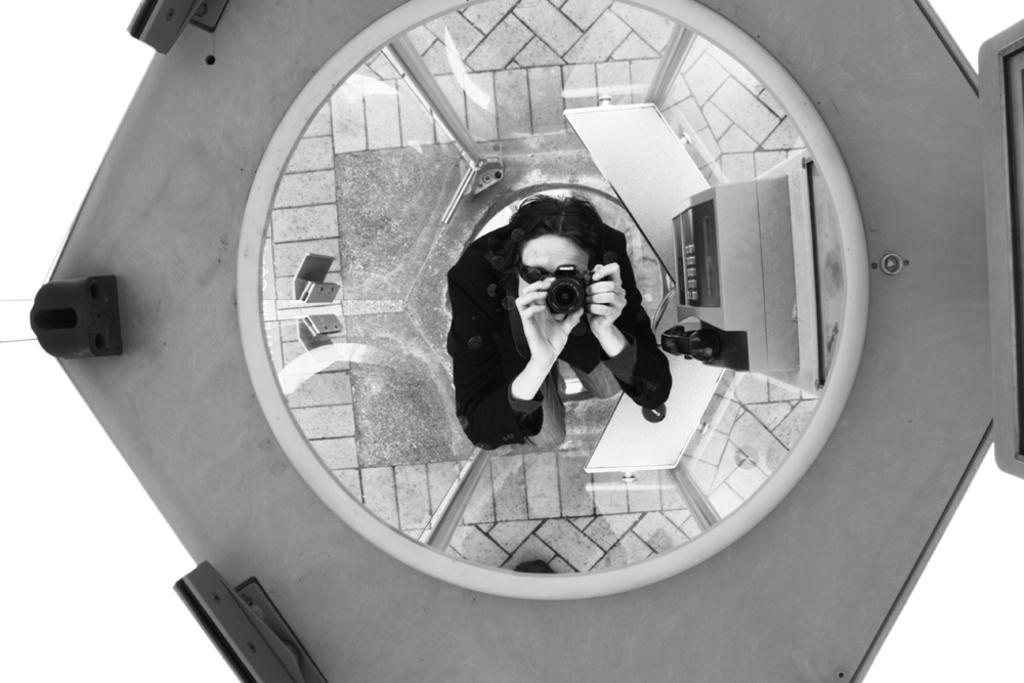Describe this image in one or two sentences. In this image I can see a person holding a camera, background I can see few objects and glass doors and the image is in black and white. 